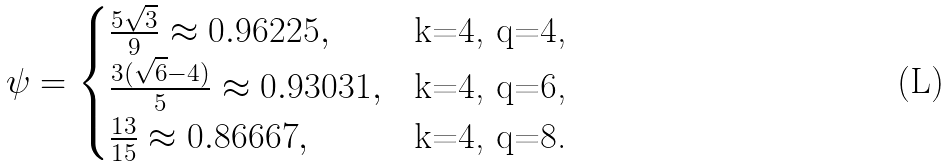<formula> <loc_0><loc_0><loc_500><loc_500>\psi = \begin{cases} \frac { 5 \sqrt { 3 } } { 9 } \approx 0 . 9 6 2 2 5 , & \text {k=4, q=4,} \\ \frac { 3 ( \sqrt { 6 } - 4 ) } { 5 } \approx 0 . 9 3 0 3 1 , & \text {k=4, q=6,} \\ \frac { 1 3 } { 1 5 } \approx 0 . 8 6 6 6 7 , & \text {k=4, q=8.} \end{cases}</formula> 